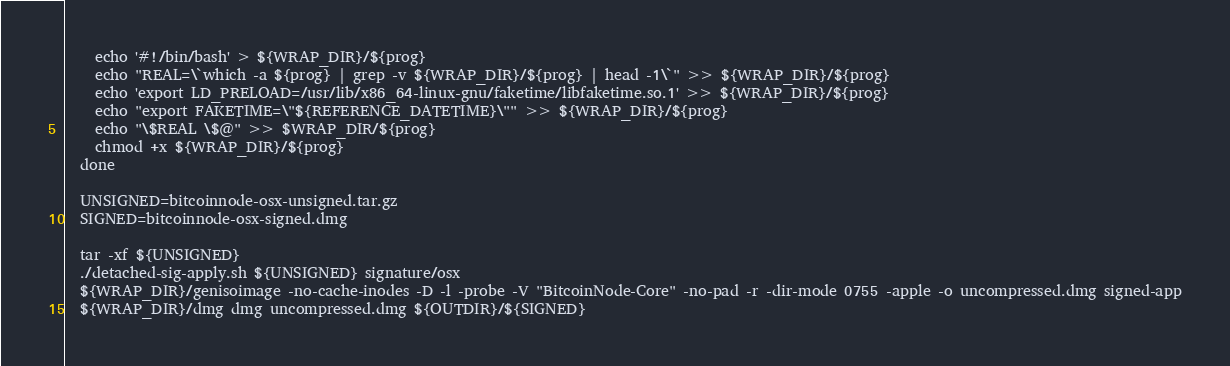Convert code to text. <code><loc_0><loc_0><loc_500><loc_500><_YAML_>    echo '#!/bin/bash' > ${WRAP_DIR}/${prog}
    echo "REAL=\`which -a ${prog} | grep -v ${WRAP_DIR}/${prog} | head -1\`" >> ${WRAP_DIR}/${prog}
    echo 'export LD_PRELOAD=/usr/lib/x86_64-linux-gnu/faketime/libfaketime.so.1' >> ${WRAP_DIR}/${prog}
    echo "export FAKETIME=\"${REFERENCE_DATETIME}\"" >> ${WRAP_DIR}/${prog}
    echo "\$REAL \$@" >> $WRAP_DIR/${prog}
    chmod +x ${WRAP_DIR}/${prog}
  done

  UNSIGNED=bitcoinnode-osx-unsigned.tar.gz
  SIGNED=bitcoinnode-osx-signed.dmg

  tar -xf ${UNSIGNED}
  ./detached-sig-apply.sh ${UNSIGNED} signature/osx
  ${WRAP_DIR}/genisoimage -no-cache-inodes -D -l -probe -V "BitcoinNode-Core" -no-pad -r -dir-mode 0755 -apple -o uncompressed.dmg signed-app
  ${WRAP_DIR}/dmg dmg uncompressed.dmg ${OUTDIR}/${SIGNED}
</code> 